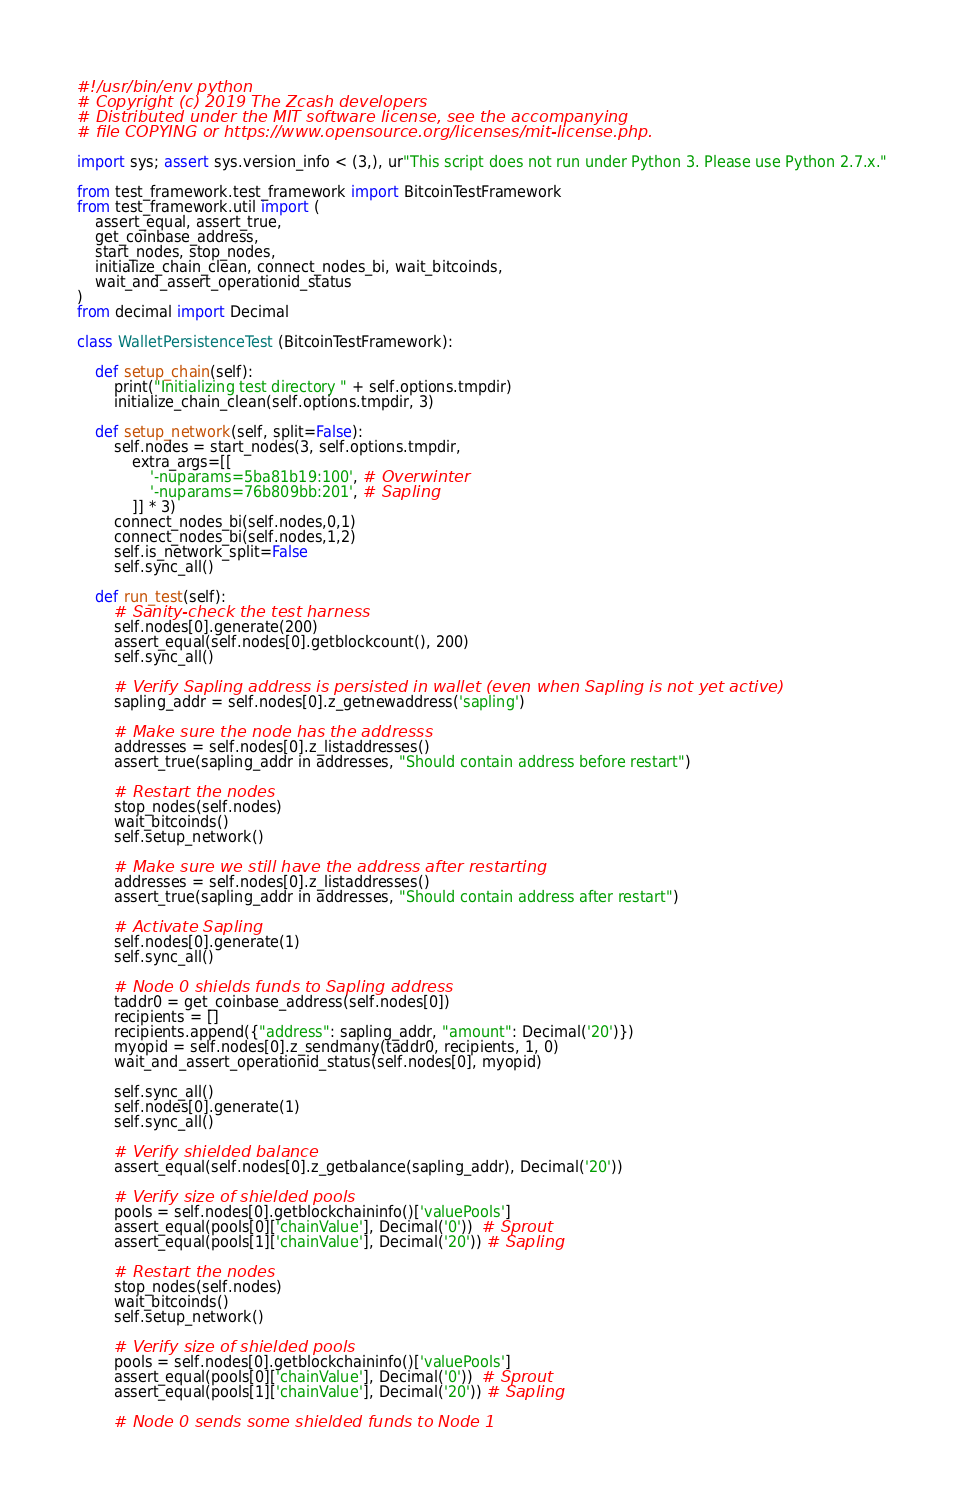Convert code to text. <code><loc_0><loc_0><loc_500><loc_500><_Python_>#!/usr/bin/env python
# Copyright (c) 2019 The Zcash developers
# Distributed under the MIT software license, see the accompanying
# file COPYING or https://www.opensource.org/licenses/mit-license.php.

import sys; assert sys.version_info < (3,), ur"This script does not run under Python 3. Please use Python 2.7.x."

from test_framework.test_framework import BitcoinTestFramework
from test_framework.util import (
    assert_equal, assert_true,
    get_coinbase_address,
    start_nodes, stop_nodes,
    initialize_chain_clean, connect_nodes_bi, wait_bitcoinds,
    wait_and_assert_operationid_status
)
from decimal import Decimal

class WalletPersistenceTest (BitcoinTestFramework):

    def setup_chain(self):
        print("Initializing test directory " + self.options.tmpdir)
        initialize_chain_clean(self.options.tmpdir, 3)

    def setup_network(self, split=False):
        self.nodes = start_nodes(3, self.options.tmpdir,
            extra_args=[[
                '-nuparams=5ba81b19:100', # Overwinter
                '-nuparams=76b809bb:201', # Sapling
            ]] * 3)
        connect_nodes_bi(self.nodes,0,1)
        connect_nodes_bi(self.nodes,1,2)
        self.is_network_split=False
        self.sync_all()

    def run_test(self):
        # Sanity-check the test harness
        self.nodes[0].generate(200)
        assert_equal(self.nodes[0].getblockcount(), 200)
        self.sync_all()

        # Verify Sapling address is persisted in wallet (even when Sapling is not yet active)
        sapling_addr = self.nodes[0].z_getnewaddress('sapling')

        # Make sure the node has the addresss
        addresses = self.nodes[0].z_listaddresses()
        assert_true(sapling_addr in addresses, "Should contain address before restart")

        # Restart the nodes
        stop_nodes(self.nodes)
        wait_bitcoinds()
        self.setup_network()

        # Make sure we still have the address after restarting
        addresses = self.nodes[0].z_listaddresses()
        assert_true(sapling_addr in addresses, "Should contain address after restart")

        # Activate Sapling
        self.nodes[0].generate(1)
        self.sync_all()

        # Node 0 shields funds to Sapling address
        taddr0 = get_coinbase_address(self.nodes[0])
        recipients = []
        recipients.append({"address": sapling_addr, "amount": Decimal('20')})
        myopid = self.nodes[0].z_sendmany(taddr0, recipients, 1, 0)
        wait_and_assert_operationid_status(self.nodes[0], myopid)

        self.sync_all()
        self.nodes[0].generate(1)
        self.sync_all()

        # Verify shielded balance
        assert_equal(self.nodes[0].z_getbalance(sapling_addr), Decimal('20'))

        # Verify size of shielded pools
        pools = self.nodes[0].getblockchaininfo()['valuePools']
        assert_equal(pools[0]['chainValue'], Decimal('0'))  # Sprout
        assert_equal(pools[1]['chainValue'], Decimal('20')) # Sapling

        # Restart the nodes
        stop_nodes(self.nodes)
        wait_bitcoinds()
        self.setup_network()

        # Verify size of shielded pools
        pools = self.nodes[0].getblockchaininfo()['valuePools']
        assert_equal(pools[0]['chainValue'], Decimal('0'))  # Sprout
        assert_equal(pools[1]['chainValue'], Decimal('20')) # Sapling

        # Node 0 sends some shielded funds to Node 1</code> 